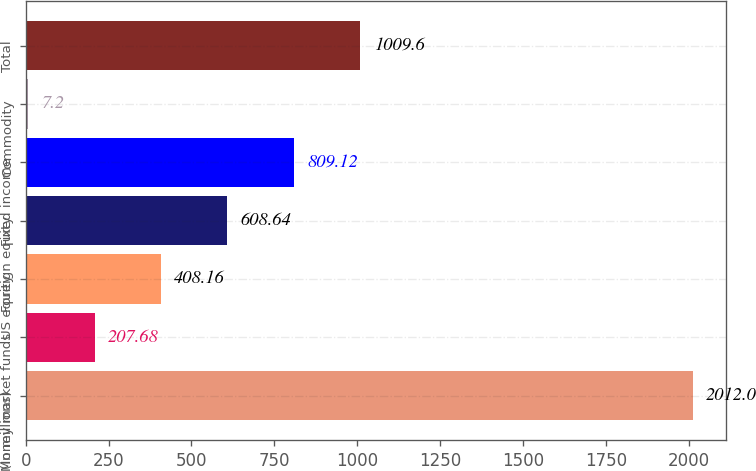<chart> <loc_0><loc_0><loc_500><loc_500><bar_chart><fcel>(in millions)<fcel>Money market funds<fcel>US equity<fcel>Foreign equity<fcel>Fixed income<fcel>Commodity<fcel>Total<nl><fcel>2012<fcel>207.68<fcel>408.16<fcel>608.64<fcel>809.12<fcel>7.2<fcel>1009.6<nl></chart> 